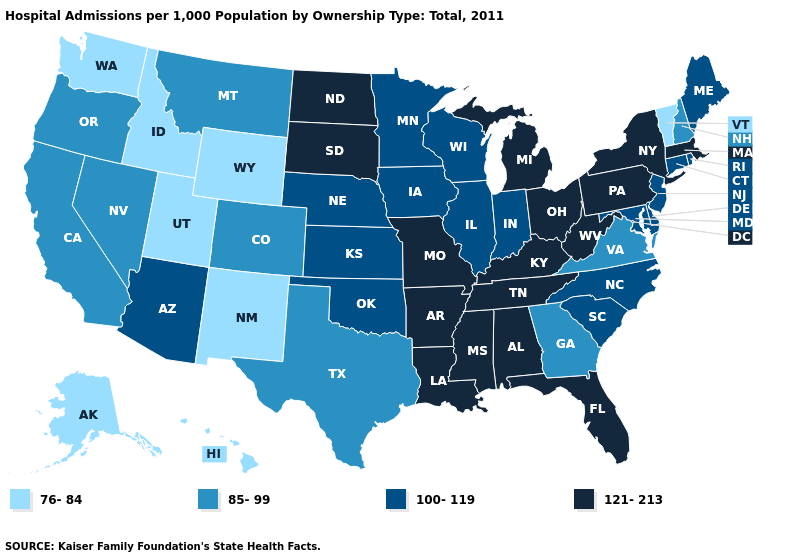What is the lowest value in states that border Maryland?
Keep it brief. 85-99. Does New Mexico have the same value as Wyoming?
Concise answer only. Yes. Does Iowa have the same value as Wyoming?
Keep it brief. No. Among the states that border West Virginia , which have the lowest value?
Be succinct. Virginia. Does Washington have the lowest value in the USA?
Answer briefly. Yes. Which states hav the highest value in the South?
Quick response, please. Alabama, Arkansas, Florida, Kentucky, Louisiana, Mississippi, Tennessee, West Virginia. What is the highest value in the USA?
Give a very brief answer. 121-213. Name the states that have a value in the range 85-99?
Answer briefly. California, Colorado, Georgia, Montana, Nevada, New Hampshire, Oregon, Texas, Virginia. What is the highest value in states that border Minnesota?
Be succinct. 121-213. Which states hav the highest value in the West?
Write a very short answer. Arizona. What is the value of Missouri?
Answer briefly. 121-213. Among the states that border Minnesota , which have the highest value?
Be succinct. North Dakota, South Dakota. What is the highest value in states that border Oregon?
Concise answer only. 85-99. What is the value of Illinois?
Short answer required. 100-119. What is the lowest value in states that border Mississippi?
Be succinct. 121-213. 